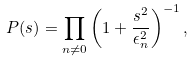<formula> <loc_0><loc_0><loc_500><loc_500>P ( s ) = \prod _ { n \neq 0 } \left ( 1 + \frac { s ^ { 2 } } { \epsilon _ { n } ^ { 2 } } \right ) ^ { - 1 } ,</formula> 